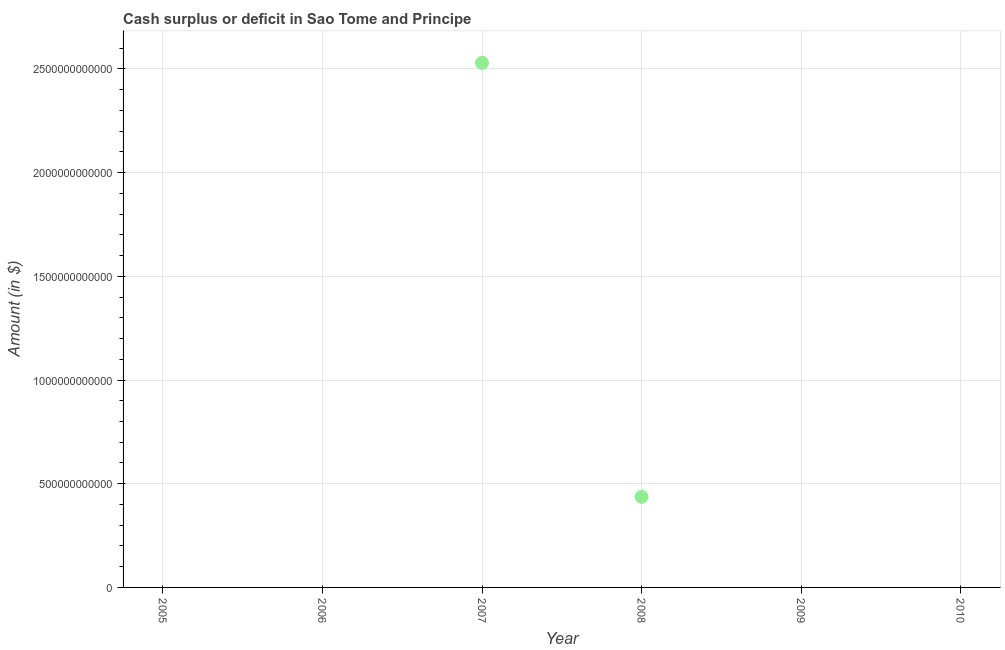What is the cash surplus or deficit in 2005?
Your answer should be very brief. 0. Across all years, what is the maximum cash surplus or deficit?
Keep it short and to the point. 2.53e+12. Across all years, what is the minimum cash surplus or deficit?
Keep it short and to the point. 0. In which year was the cash surplus or deficit maximum?
Your answer should be compact. 2007. What is the sum of the cash surplus or deficit?
Offer a very short reply. 2.97e+12. What is the difference between the cash surplus or deficit in 2007 and 2008?
Make the answer very short. 2.09e+12. What is the average cash surplus or deficit per year?
Ensure brevity in your answer.  4.94e+11. What is the difference between the highest and the lowest cash surplus or deficit?
Offer a very short reply. 2.53e+12. In how many years, is the cash surplus or deficit greater than the average cash surplus or deficit taken over all years?
Your answer should be compact. 1. How many years are there in the graph?
Your answer should be compact. 6. What is the difference between two consecutive major ticks on the Y-axis?
Offer a terse response. 5.00e+11. Are the values on the major ticks of Y-axis written in scientific E-notation?
Ensure brevity in your answer.  No. What is the title of the graph?
Provide a short and direct response. Cash surplus or deficit in Sao Tome and Principe. What is the label or title of the X-axis?
Ensure brevity in your answer.  Year. What is the label or title of the Y-axis?
Make the answer very short. Amount (in $). What is the Amount (in $) in 2005?
Keep it short and to the point. 0. What is the Amount (in $) in 2007?
Provide a succinct answer. 2.53e+12. What is the Amount (in $) in 2008?
Ensure brevity in your answer.  4.36e+11. What is the Amount (in $) in 2009?
Your response must be concise. 0. What is the difference between the Amount (in $) in 2007 and 2008?
Your answer should be very brief. 2.09e+12. What is the ratio of the Amount (in $) in 2007 to that in 2008?
Keep it short and to the point. 5.79. 